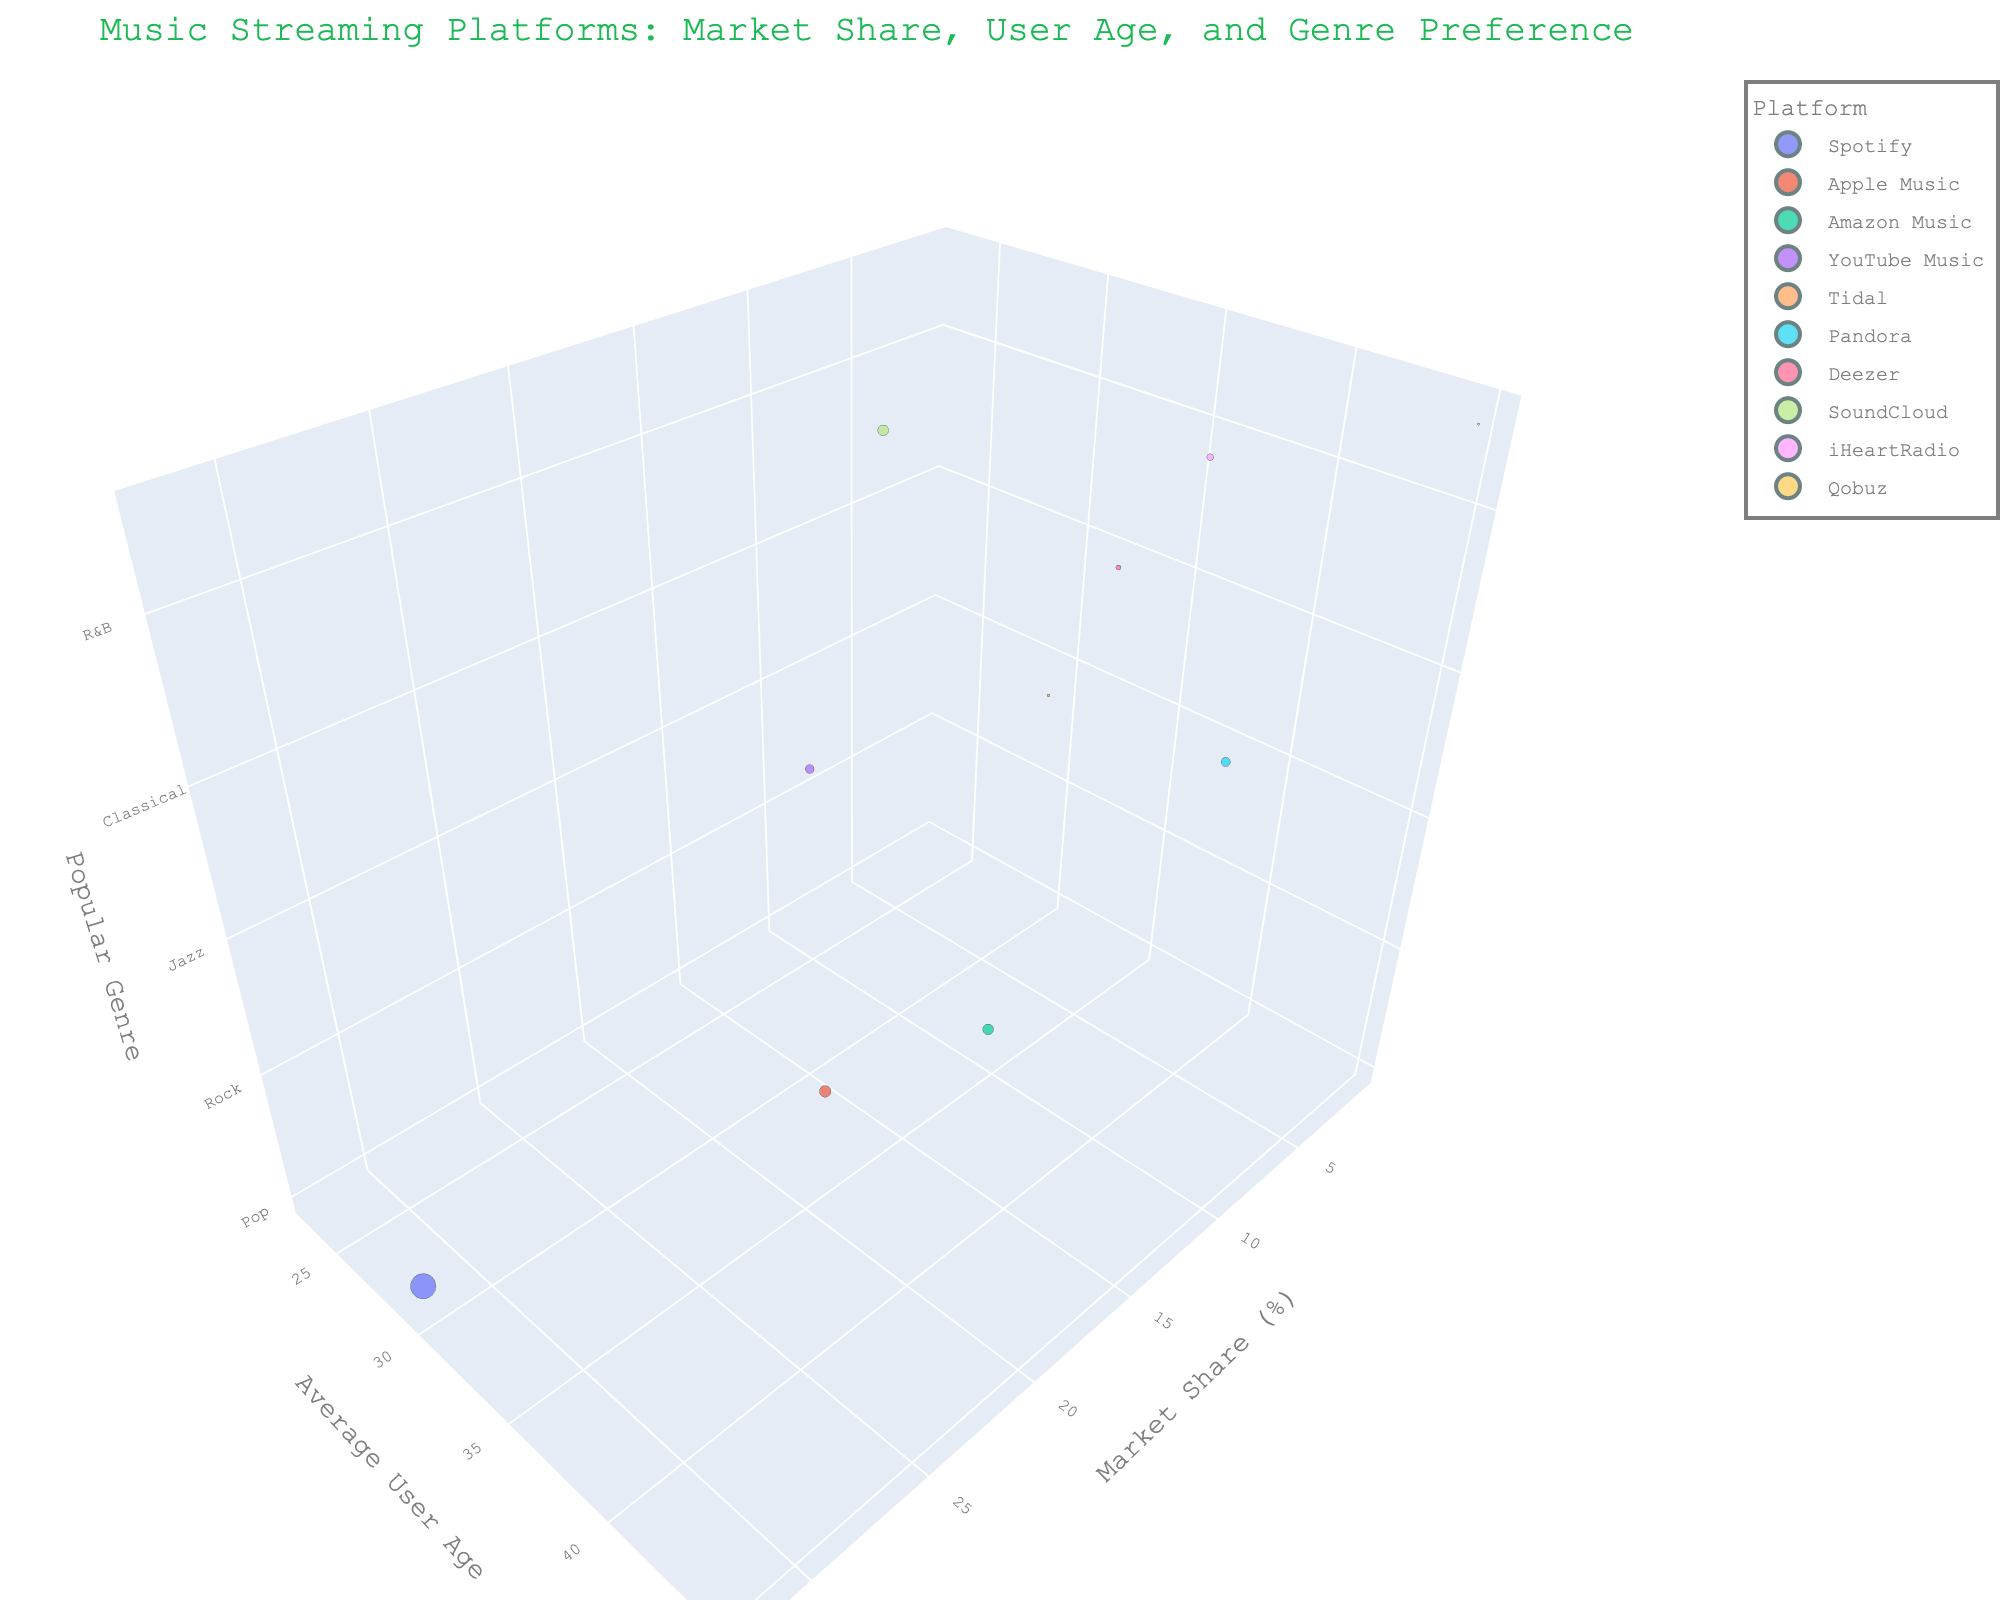What's the title of the figure? The title of the figure is displayed at the top and provides a summary of the content being visualized. In this case, we are comparing music streaming platforms based on different factors like market share, user age, and genre preferences.
Answer: Music Streaming Platforms: Market Share, User Age, and Genre Preference Which music streaming platform has the highest market share? The Market Share (%) is shown on the x-axis. We look for the data point farthest to the right along this axis, which represents the highest market share. In this case, Spotify's bubble is the farthest to the right.
Answer: Spotify What is the most popular genre for platforms with an average user age of 30 or above? We need to check the y-axis for platforms with an average user age of 30 or above and then look at the z-axis (Popular Genre) for those corresponding bubbles. The genres we have are Pop (Spotify), Hip-Hop (Apple Music), Jazz (Tidal), Country (Pandora), and Classical (Deezer).
Answer: Pop, Hip-Hop, Jazz, Country, Classical Which platform has the smallest user base but still appears on the chart? The size of the bubble represents the user base. The smallest bubble on the chart corresponds to this platform. Checking the bubbles, it is Qobuz.
Answer: Qobuz What is the average user age for Apple Music and Spotify? We look at the y-axis values for both Apple Music and Spotify and calculate the average. Apple Music's average user age is 34 and Spotify's is 29. The average is (34 + 29) / 2.
Answer: 31.5 Among the platforms, which one has an average user age closest to 35? We look at the y-axis for the data point closest to 35. Deezer has an average user age of 33, which is the closest to 35 among the platforms.
Answer: Deezer Which platforms have market shares less than 5%? We need to check the x-axis for platforms positioned to the left of the 5% mark. The platforms that meet this criterion are Tidal, Deezer, SoundCloud, iHeartRadio, and Qobuz.
Answer: Tidal, Deezer, SoundCloud, iHeartRadio, Qobuz Does any platform with an average user age over 40 have more than a 5% market share? First, identify platforms with a user age over 40 using the y-axis. Pandora is the only platform that meets this criterion. Then check if its market share on the x-axis is above 5%. Pandora has a 6% market share.
Answer: Yes, Pandora Which genre is most popular among users around the age of 25? We look at the y-axis for a value close to 25 and then check the z-axis to find the genre. YouTube Music at age 25 has Electronic as the most popular genre.
Answer: Electronic What is the total user base of the platforms with a market share of 10% or more? We sum the user bases of the platforms with a market share of 10% or more. These platforms are Spotify (422 million), Apple Music (88 million), and Amazon Music (75 million). The total user base is 422 + 88 + 75.
Answer: 585 million 